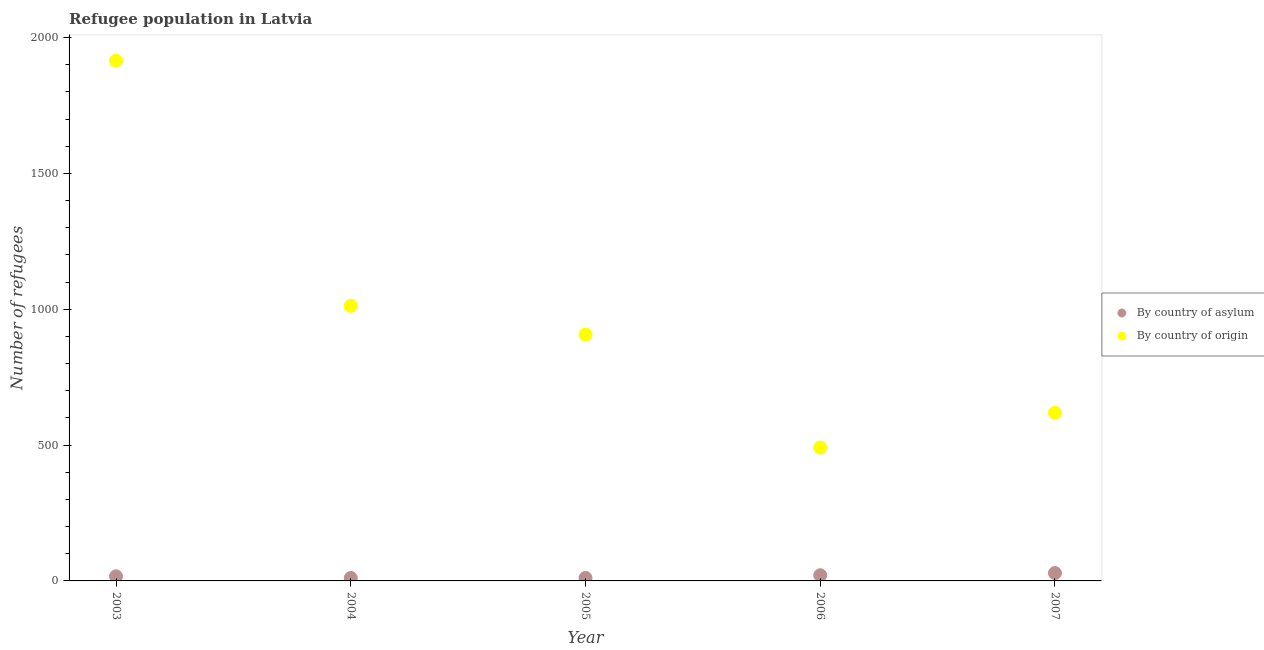How many different coloured dotlines are there?
Provide a succinct answer. 2. Is the number of dotlines equal to the number of legend labels?
Keep it short and to the point. Yes. What is the number of refugees by country of origin in 2007?
Provide a succinct answer. 619. Across all years, what is the maximum number of refugees by country of asylum?
Provide a short and direct response. 29. Across all years, what is the minimum number of refugees by country of origin?
Your answer should be very brief. 491. What is the total number of refugees by country of asylum in the graph?
Offer a very short reply. 89. What is the difference between the number of refugees by country of origin in 2004 and that in 2007?
Offer a very short reply. 394. What is the difference between the number of refugees by country of asylum in 2007 and the number of refugees by country of origin in 2006?
Your answer should be very brief. -462. What is the average number of refugees by country of origin per year?
Offer a terse response. 989. In the year 2005, what is the difference between the number of refugees by country of origin and number of refugees by country of asylum?
Keep it short and to the point. 896. In how many years, is the number of refugees by country of asylum greater than 300?
Make the answer very short. 0. What is the ratio of the number of refugees by country of origin in 2006 to that in 2007?
Offer a terse response. 0.79. Is the number of refugees by country of asylum in 2004 less than that in 2005?
Your answer should be compact. No. Is the difference between the number of refugees by country of origin in 2006 and 2007 greater than the difference between the number of refugees by country of asylum in 2006 and 2007?
Your response must be concise. No. What is the difference between the highest and the second highest number of refugees by country of origin?
Offer a very short reply. 902. What is the difference between the highest and the lowest number of refugees by country of asylum?
Provide a short and direct response. 18. Does the number of refugees by country of asylum monotonically increase over the years?
Offer a terse response. No. Is the number of refugees by country of origin strictly less than the number of refugees by country of asylum over the years?
Provide a short and direct response. No. How many dotlines are there?
Make the answer very short. 2. Are the values on the major ticks of Y-axis written in scientific E-notation?
Keep it short and to the point. No. Does the graph contain any zero values?
Your response must be concise. No. Does the graph contain grids?
Your response must be concise. No. Where does the legend appear in the graph?
Your answer should be very brief. Center right. How many legend labels are there?
Your answer should be very brief. 2. What is the title of the graph?
Provide a succinct answer. Refugee population in Latvia. Does "Public credit registry" appear as one of the legend labels in the graph?
Ensure brevity in your answer.  No. What is the label or title of the X-axis?
Offer a terse response. Year. What is the label or title of the Y-axis?
Offer a terse response. Number of refugees. What is the Number of refugees in By country of origin in 2003?
Keep it short and to the point. 1915. What is the Number of refugees of By country of asylum in 2004?
Your response must be concise. 11. What is the Number of refugees in By country of origin in 2004?
Your response must be concise. 1013. What is the Number of refugees in By country of asylum in 2005?
Provide a short and direct response. 11. What is the Number of refugees of By country of origin in 2005?
Ensure brevity in your answer.  907. What is the Number of refugees of By country of asylum in 2006?
Your answer should be compact. 21. What is the Number of refugees in By country of origin in 2006?
Ensure brevity in your answer.  491. What is the Number of refugees of By country of asylum in 2007?
Provide a succinct answer. 29. What is the Number of refugees of By country of origin in 2007?
Offer a very short reply. 619. Across all years, what is the maximum Number of refugees of By country of asylum?
Your answer should be compact. 29. Across all years, what is the maximum Number of refugees in By country of origin?
Offer a very short reply. 1915. Across all years, what is the minimum Number of refugees in By country of origin?
Ensure brevity in your answer.  491. What is the total Number of refugees of By country of asylum in the graph?
Your response must be concise. 89. What is the total Number of refugees of By country of origin in the graph?
Your answer should be very brief. 4945. What is the difference between the Number of refugees in By country of origin in 2003 and that in 2004?
Ensure brevity in your answer.  902. What is the difference between the Number of refugees of By country of origin in 2003 and that in 2005?
Your answer should be compact. 1008. What is the difference between the Number of refugees of By country of asylum in 2003 and that in 2006?
Offer a very short reply. -4. What is the difference between the Number of refugees in By country of origin in 2003 and that in 2006?
Provide a short and direct response. 1424. What is the difference between the Number of refugees of By country of asylum in 2003 and that in 2007?
Offer a very short reply. -12. What is the difference between the Number of refugees of By country of origin in 2003 and that in 2007?
Offer a very short reply. 1296. What is the difference between the Number of refugees of By country of asylum in 2004 and that in 2005?
Your response must be concise. 0. What is the difference between the Number of refugees of By country of origin in 2004 and that in 2005?
Make the answer very short. 106. What is the difference between the Number of refugees in By country of origin in 2004 and that in 2006?
Keep it short and to the point. 522. What is the difference between the Number of refugees of By country of origin in 2004 and that in 2007?
Make the answer very short. 394. What is the difference between the Number of refugees of By country of origin in 2005 and that in 2006?
Make the answer very short. 416. What is the difference between the Number of refugees in By country of asylum in 2005 and that in 2007?
Offer a very short reply. -18. What is the difference between the Number of refugees of By country of origin in 2005 and that in 2007?
Provide a succinct answer. 288. What is the difference between the Number of refugees of By country of origin in 2006 and that in 2007?
Offer a very short reply. -128. What is the difference between the Number of refugees of By country of asylum in 2003 and the Number of refugees of By country of origin in 2004?
Provide a short and direct response. -996. What is the difference between the Number of refugees in By country of asylum in 2003 and the Number of refugees in By country of origin in 2005?
Make the answer very short. -890. What is the difference between the Number of refugees of By country of asylum in 2003 and the Number of refugees of By country of origin in 2006?
Your response must be concise. -474. What is the difference between the Number of refugees of By country of asylum in 2003 and the Number of refugees of By country of origin in 2007?
Give a very brief answer. -602. What is the difference between the Number of refugees of By country of asylum in 2004 and the Number of refugees of By country of origin in 2005?
Provide a succinct answer. -896. What is the difference between the Number of refugees in By country of asylum in 2004 and the Number of refugees in By country of origin in 2006?
Your answer should be compact. -480. What is the difference between the Number of refugees of By country of asylum in 2004 and the Number of refugees of By country of origin in 2007?
Your answer should be compact. -608. What is the difference between the Number of refugees of By country of asylum in 2005 and the Number of refugees of By country of origin in 2006?
Your answer should be very brief. -480. What is the difference between the Number of refugees in By country of asylum in 2005 and the Number of refugees in By country of origin in 2007?
Provide a short and direct response. -608. What is the difference between the Number of refugees in By country of asylum in 2006 and the Number of refugees in By country of origin in 2007?
Provide a succinct answer. -598. What is the average Number of refugees of By country of asylum per year?
Offer a terse response. 17.8. What is the average Number of refugees of By country of origin per year?
Offer a very short reply. 989. In the year 2003, what is the difference between the Number of refugees of By country of asylum and Number of refugees of By country of origin?
Your answer should be compact. -1898. In the year 2004, what is the difference between the Number of refugees in By country of asylum and Number of refugees in By country of origin?
Offer a terse response. -1002. In the year 2005, what is the difference between the Number of refugees in By country of asylum and Number of refugees in By country of origin?
Make the answer very short. -896. In the year 2006, what is the difference between the Number of refugees of By country of asylum and Number of refugees of By country of origin?
Make the answer very short. -470. In the year 2007, what is the difference between the Number of refugees of By country of asylum and Number of refugees of By country of origin?
Offer a terse response. -590. What is the ratio of the Number of refugees in By country of asylum in 2003 to that in 2004?
Ensure brevity in your answer.  1.55. What is the ratio of the Number of refugees of By country of origin in 2003 to that in 2004?
Keep it short and to the point. 1.89. What is the ratio of the Number of refugees of By country of asylum in 2003 to that in 2005?
Make the answer very short. 1.55. What is the ratio of the Number of refugees in By country of origin in 2003 to that in 2005?
Keep it short and to the point. 2.11. What is the ratio of the Number of refugees of By country of asylum in 2003 to that in 2006?
Your answer should be very brief. 0.81. What is the ratio of the Number of refugees in By country of origin in 2003 to that in 2006?
Make the answer very short. 3.9. What is the ratio of the Number of refugees in By country of asylum in 2003 to that in 2007?
Offer a very short reply. 0.59. What is the ratio of the Number of refugees in By country of origin in 2003 to that in 2007?
Offer a terse response. 3.09. What is the ratio of the Number of refugees of By country of origin in 2004 to that in 2005?
Offer a terse response. 1.12. What is the ratio of the Number of refugees of By country of asylum in 2004 to that in 2006?
Give a very brief answer. 0.52. What is the ratio of the Number of refugees of By country of origin in 2004 to that in 2006?
Your response must be concise. 2.06. What is the ratio of the Number of refugees of By country of asylum in 2004 to that in 2007?
Make the answer very short. 0.38. What is the ratio of the Number of refugees of By country of origin in 2004 to that in 2007?
Provide a short and direct response. 1.64. What is the ratio of the Number of refugees of By country of asylum in 2005 to that in 2006?
Your response must be concise. 0.52. What is the ratio of the Number of refugees of By country of origin in 2005 to that in 2006?
Offer a terse response. 1.85. What is the ratio of the Number of refugees of By country of asylum in 2005 to that in 2007?
Make the answer very short. 0.38. What is the ratio of the Number of refugees in By country of origin in 2005 to that in 2007?
Keep it short and to the point. 1.47. What is the ratio of the Number of refugees in By country of asylum in 2006 to that in 2007?
Provide a succinct answer. 0.72. What is the ratio of the Number of refugees in By country of origin in 2006 to that in 2007?
Give a very brief answer. 0.79. What is the difference between the highest and the second highest Number of refugees in By country of asylum?
Ensure brevity in your answer.  8. What is the difference between the highest and the second highest Number of refugees in By country of origin?
Provide a short and direct response. 902. What is the difference between the highest and the lowest Number of refugees in By country of origin?
Offer a very short reply. 1424. 